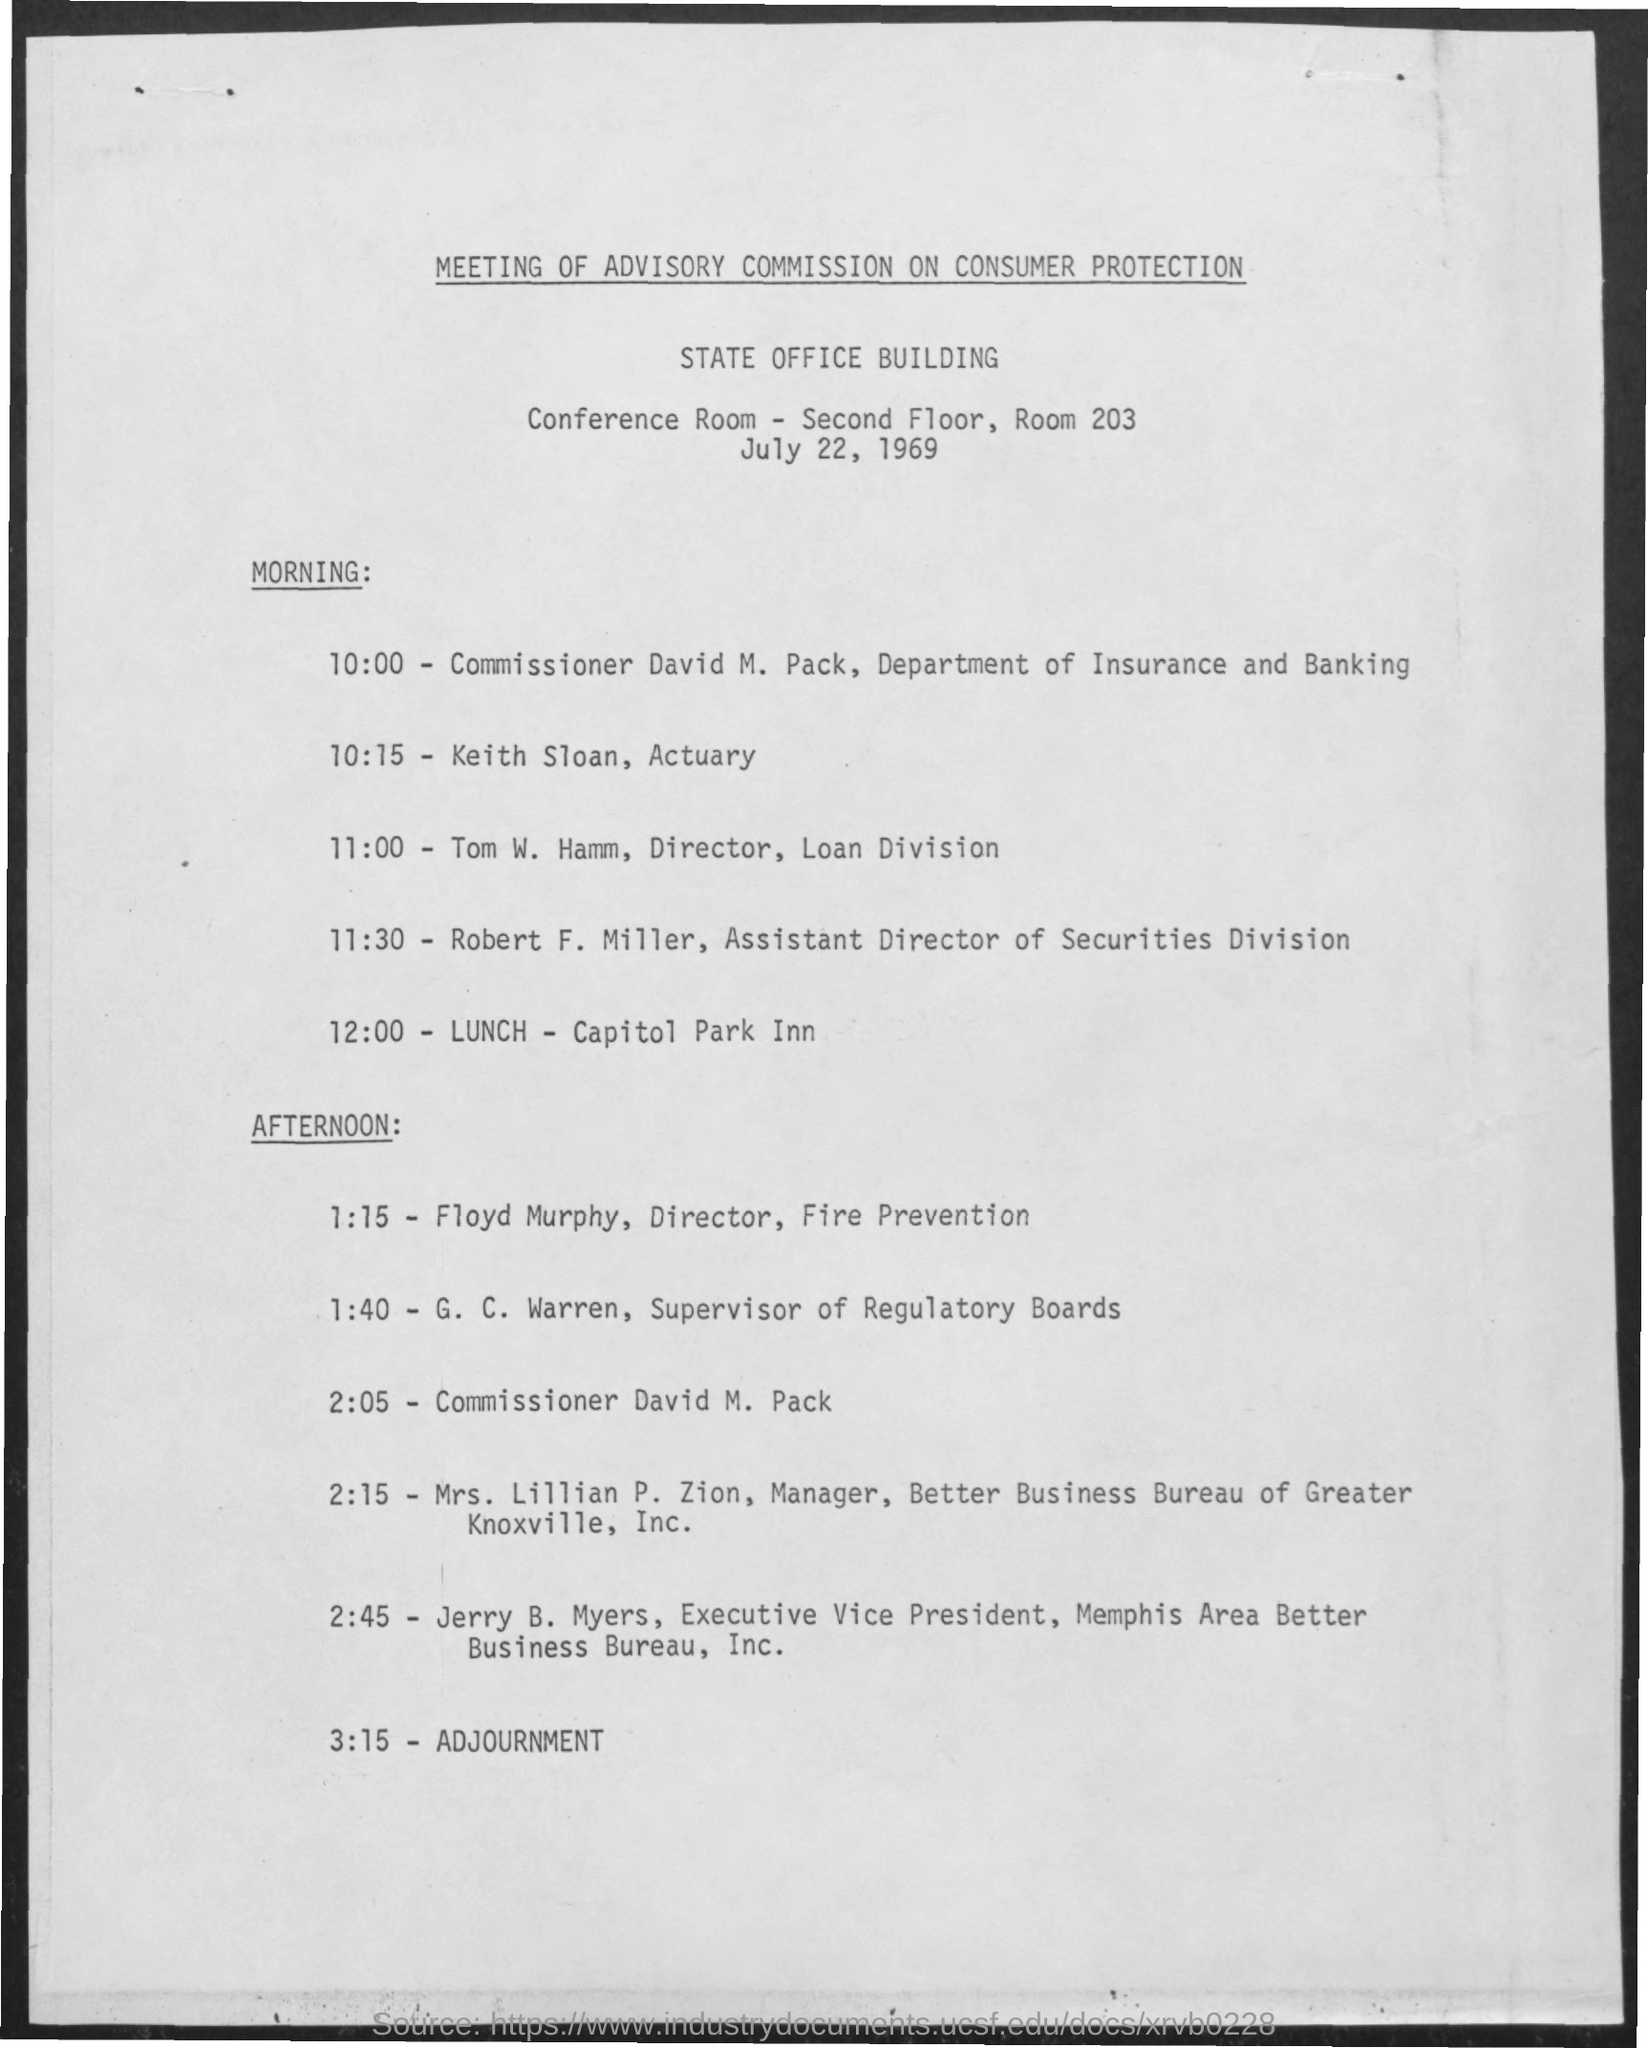Are there any notable names listed on the schedule? While the document doesn't specify the notability of the individuals, it does list several names with official titles, such as commissioners and directors. These titles suggest that those mentioned held significant positions in their respective departments or organizations. 